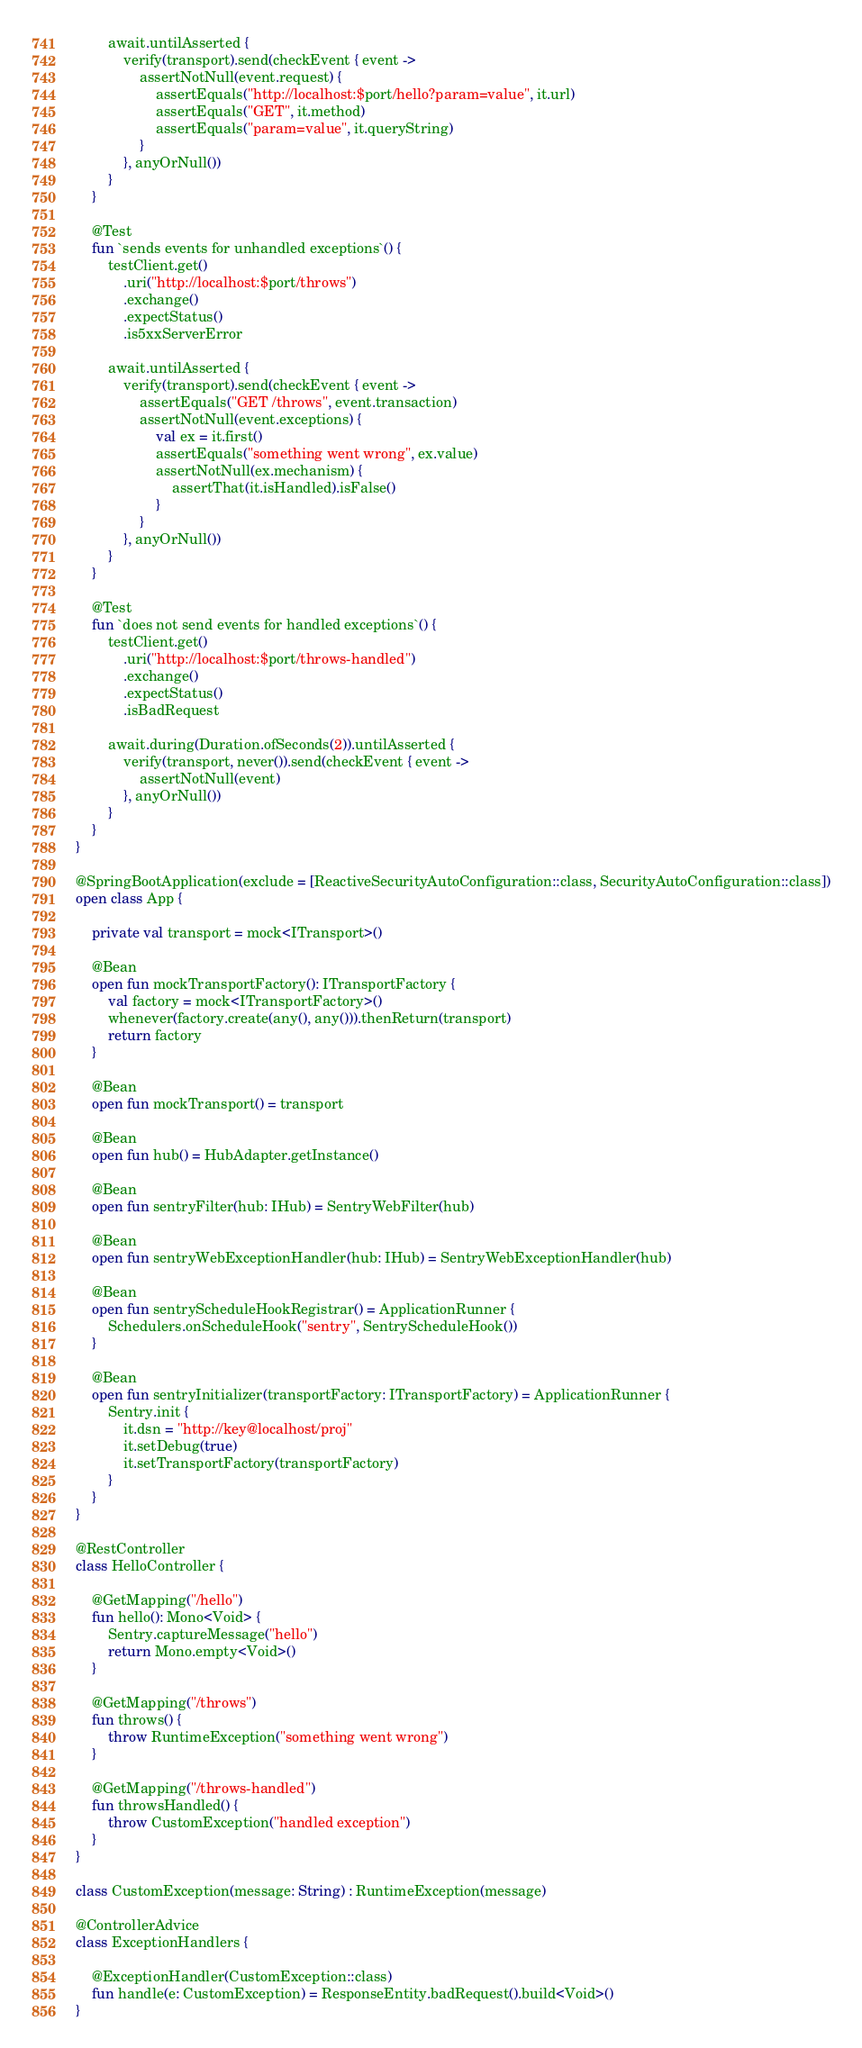Convert code to text. <code><loc_0><loc_0><loc_500><loc_500><_Kotlin_>
        await.untilAsserted {
            verify(transport).send(checkEvent { event ->
                assertNotNull(event.request) {
                    assertEquals("http://localhost:$port/hello?param=value", it.url)
                    assertEquals("GET", it.method)
                    assertEquals("param=value", it.queryString)
                }
            }, anyOrNull())
        }
    }

    @Test
    fun `sends events for unhandled exceptions`() {
        testClient.get()
            .uri("http://localhost:$port/throws")
            .exchange()
            .expectStatus()
            .is5xxServerError

        await.untilAsserted {
            verify(transport).send(checkEvent { event ->
                assertEquals("GET /throws", event.transaction)
                assertNotNull(event.exceptions) {
                    val ex = it.first()
                    assertEquals("something went wrong", ex.value)
                    assertNotNull(ex.mechanism) {
                        assertThat(it.isHandled).isFalse()
                    }
                }
            }, anyOrNull())
        }
    }

    @Test
    fun `does not send events for handled exceptions`() {
        testClient.get()
            .uri("http://localhost:$port/throws-handled")
            .exchange()
            .expectStatus()
            .isBadRequest

        await.during(Duration.ofSeconds(2)).untilAsserted {
            verify(transport, never()).send(checkEvent { event ->
                assertNotNull(event)
            }, anyOrNull())
        }
    }
}

@SpringBootApplication(exclude = [ReactiveSecurityAutoConfiguration::class, SecurityAutoConfiguration::class])
open class App {

    private val transport = mock<ITransport>()

    @Bean
    open fun mockTransportFactory(): ITransportFactory {
        val factory = mock<ITransportFactory>()
        whenever(factory.create(any(), any())).thenReturn(transport)
        return factory
    }

    @Bean
    open fun mockTransport() = transport

    @Bean
    open fun hub() = HubAdapter.getInstance()

    @Bean
    open fun sentryFilter(hub: IHub) = SentryWebFilter(hub)

    @Bean
    open fun sentryWebExceptionHandler(hub: IHub) = SentryWebExceptionHandler(hub)

    @Bean
    open fun sentryScheduleHookRegistrar() = ApplicationRunner {
        Schedulers.onScheduleHook("sentry", SentryScheduleHook())
    }

    @Bean
    open fun sentryInitializer(transportFactory: ITransportFactory) = ApplicationRunner {
        Sentry.init {
            it.dsn = "http://key@localhost/proj"
            it.setDebug(true)
            it.setTransportFactory(transportFactory)
        }
    }
}

@RestController
class HelloController {

    @GetMapping("/hello")
    fun hello(): Mono<Void> {
        Sentry.captureMessage("hello")
        return Mono.empty<Void>()
    }

    @GetMapping("/throws")
    fun throws() {
        throw RuntimeException("something went wrong")
    }

    @GetMapping("/throws-handled")
    fun throwsHandled() {
        throw CustomException("handled exception")
    }
}

class CustomException(message: String) : RuntimeException(message)

@ControllerAdvice
class ExceptionHandlers {

    @ExceptionHandler(CustomException::class)
    fun handle(e: CustomException) = ResponseEntity.badRequest().build<Void>()
}
</code> 